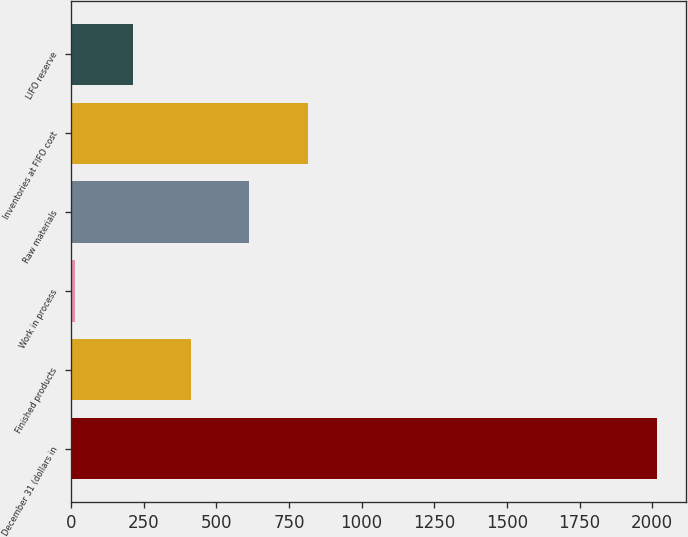Convert chart to OTSL. <chart><loc_0><loc_0><loc_500><loc_500><bar_chart><fcel>December 31 (dollars in<fcel>Finished products<fcel>Work in process<fcel>Raw materials<fcel>Inventories at FIFO cost<fcel>LIFO reserve<nl><fcel>2015<fcel>413.72<fcel>13.4<fcel>613.88<fcel>814.04<fcel>213.56<nl></chart> 